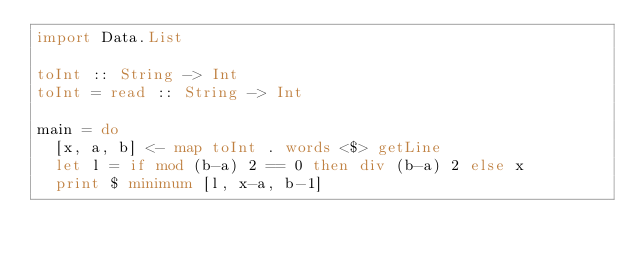<code> <loc_0><loc_0><loc_500><loc_500><_Haskell_>import Data.List

toInt :: String -> Int
toInt = read :: String -> Int

main = do
  [x, a, b] <- map toInt . words <$> getLine
  let l = if mod (b-a) 2 == 0 then div (b-a) 2 else x
  print $ minimum [l, x-a, b-1]
</code> 